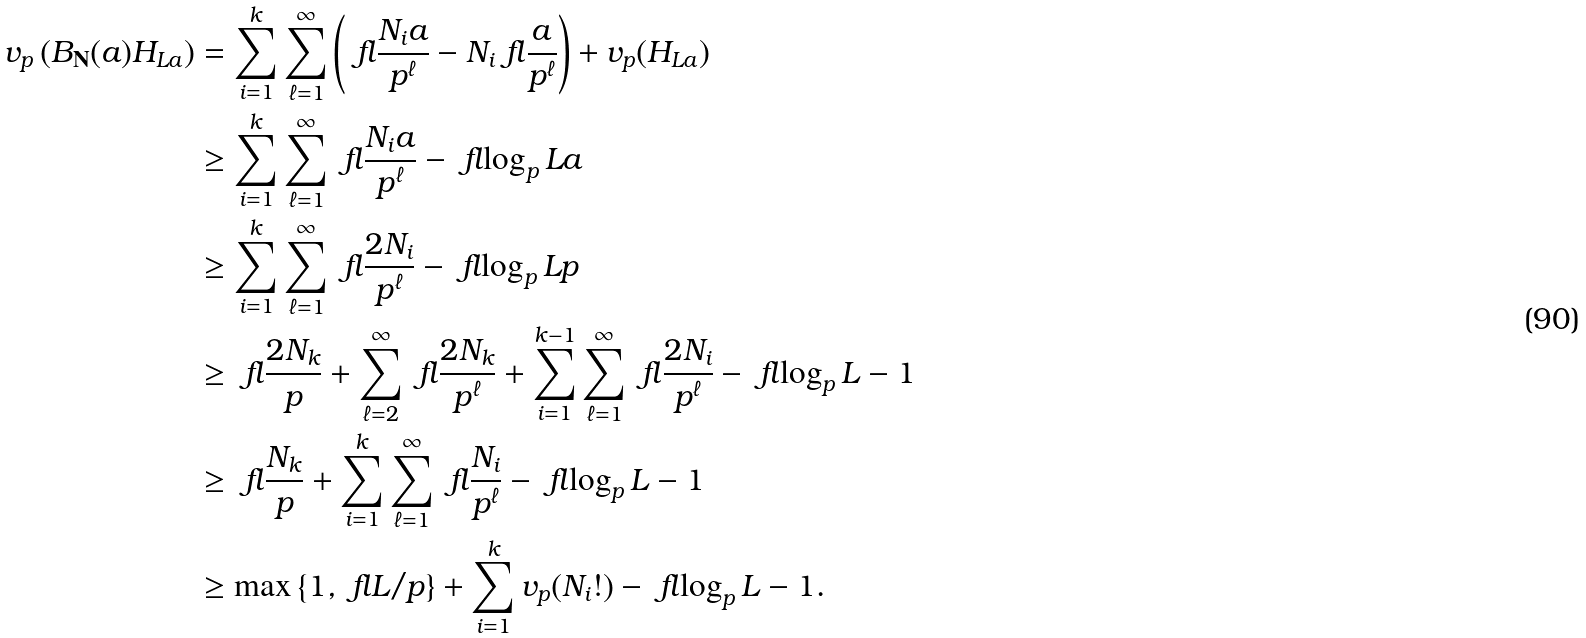<formula> <loc_0><loc_0><loc_500><loc_500>v _ { p } \left ( B _ { \mathbf N } ( a ) H _ { L a } \right ) & = \sum _ { i = 1 } ^ { k } \sum _ { \ell = 1 } ^ { \infty } \left ( \ f l { \frac { N _ { i } a } { p ^ { \ell } } } - N _ { i } \ f l { \frac { a } { p ^ { \ell } } } \right ) + v _ { p } ( H _ { L a } ) \\ & \geq \sum _ { i = 1 } ^ { k } \sum _ { \ell = 1 } ^ { \infty } \ f l { \frac { N _ { i } a } { p ^ { \ell } } } - \ f l { \log _ { p } L a } \\ & \geq \sum _ { i = 1 } ^ { k } \sum _ { \ell = 1 } ^ { \infty } \ f l { \frac { 2 N _ { i } } { p ^ { \ell } } } - \ f l { \log _ { p } L p } \\ & \geq \ f l { \frac { 2 N _ { k } } { p } } + \sum _ { \ell = 2 } ^ { \infty } \ f l { \frac { 2 N _ { k } } { p ^ { \ell } } } + \sum _ { i = 1 } ^ { k - 1 } \sum _ { \ell = 1 } ^ { \infty } \ f l { \frac { 2 N _ { i } } { p ^ { \ell } } } - \ f l { \log _ { p } L } - 1 \\ & \geq \ f l { \frac { N _ { k } } { p } } + \sum _ { i = 1 } ^ { k } \sum _ { \ell = 1 } ^ { \infty } \ f l { \frac { N _ { i } } { p ^ { \ell } } } - \ f l { \log _ { p } L } - 1 \\ & \geq \max \left \{ 1 , \ f l { L / p } \right \} + \sum _ { i = 1 } ^ { k } v _ { p } ( N _ { i } ! ) - \ f l { \log _ { p } L } - 1 .</formula> 